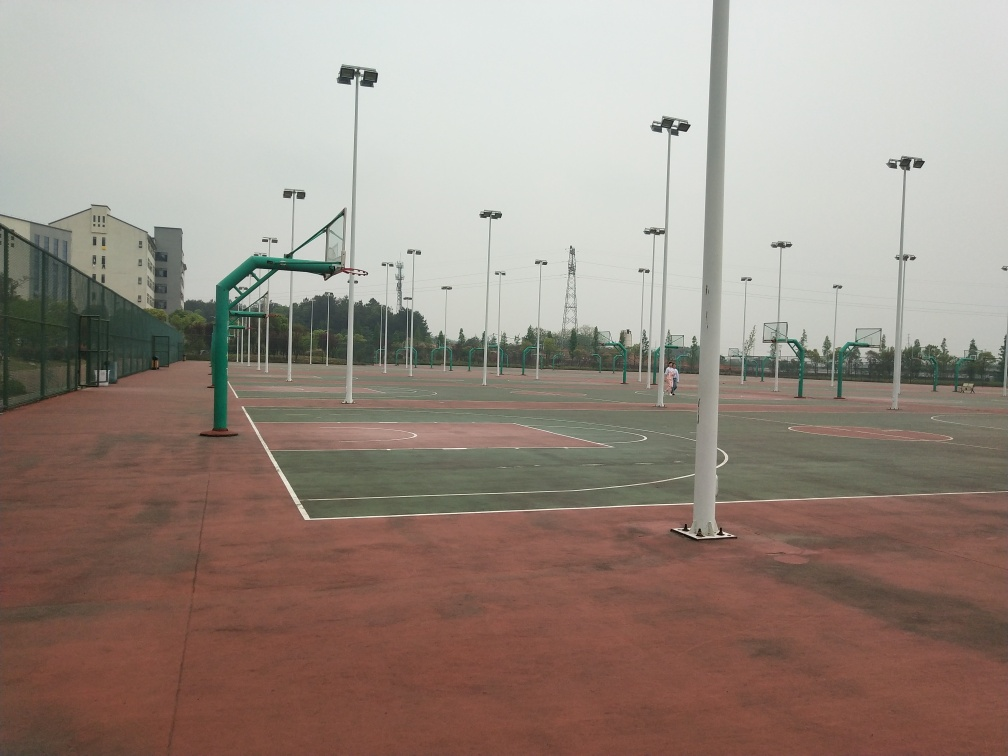What would be the best time of day to use this basketball court? This basketball court is equipped with tall lighting poles, indicating that it can be used in the evening when natural light is insufficient. The best time would depend on personal preference, though typically mornings and evenings are cooler and more comfortable for outdoor sports, and the installed lights make evening play a viable and enjoyable option. 